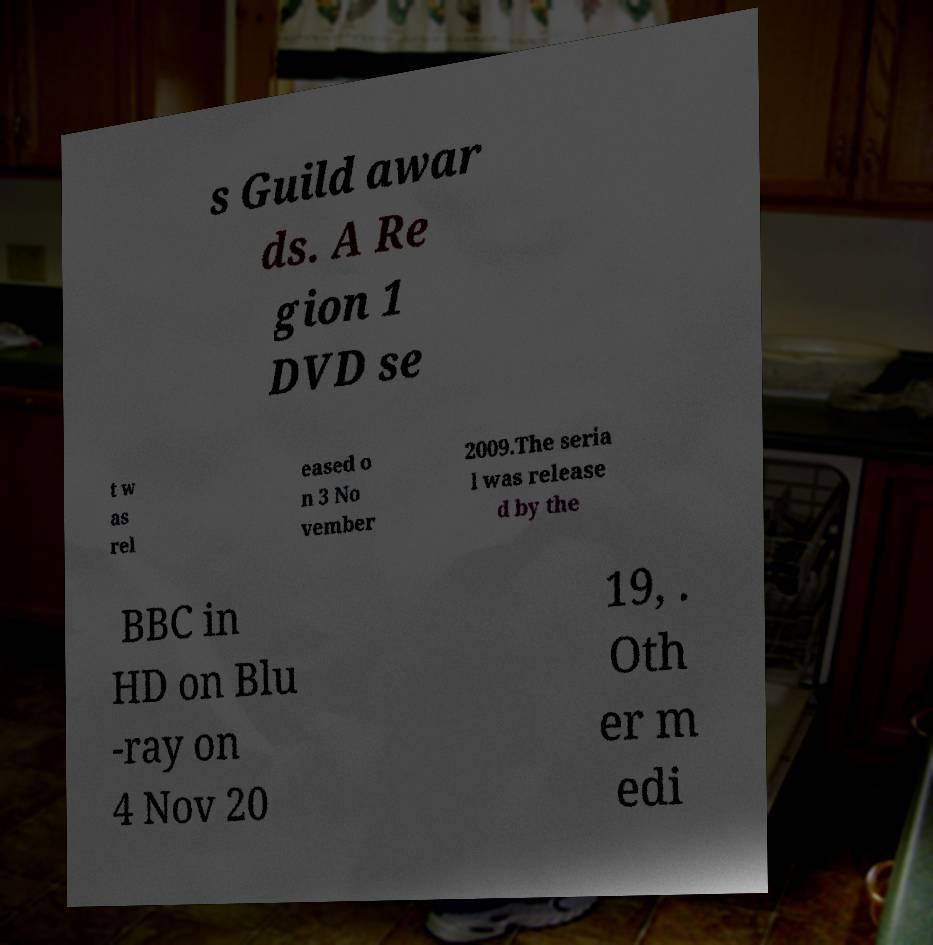For documentation purposes, I need the text within this image transcribed. Could you provide that? s Guild awar ds. A Re gion 1 DVD se t w as rel eased o n 3 No vember 2009.The seria l was release d by the BBC in HD on Blu -ray on 4 Nov 20 19, . Oth er m edi 